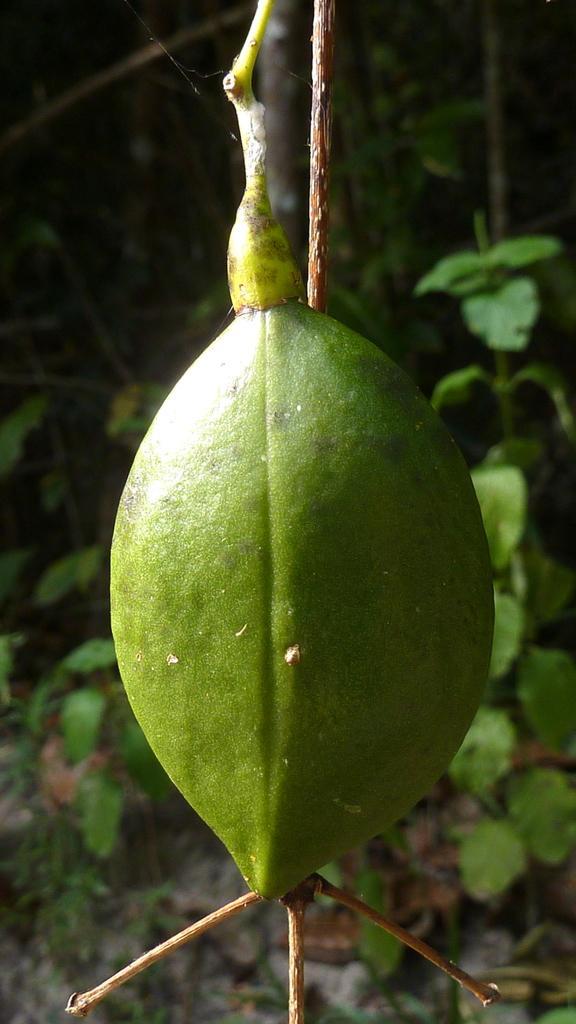Could you give a brief overview of what you see in this image? In this picture it looks like a reptile crawling on a plant. 